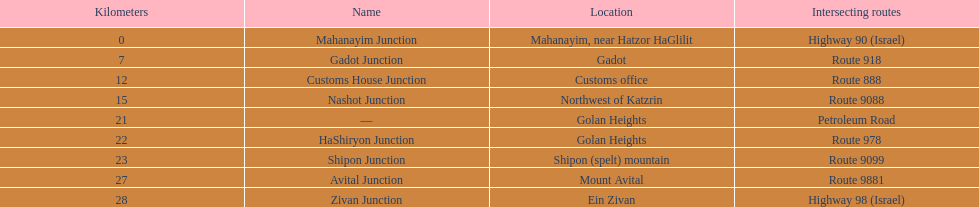What is the final intersection on highway 91? Zivan Junction. 